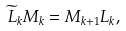Convert formula to latex. <formula><loc_0><loc_0><loc_500><loc_500>\widetilde { L } _ { k } M _ { k } = M _ { k + 1 } L _ { k } ,</formula> 